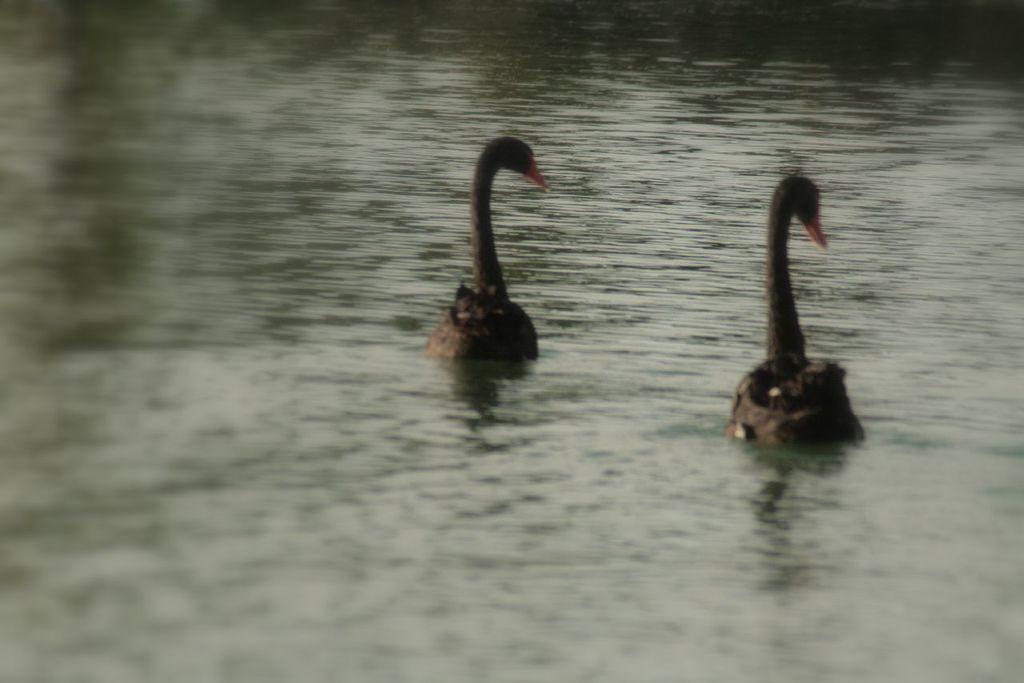How would you summarize this image in a sentence or two? In the center of the image there are birds in the water. 